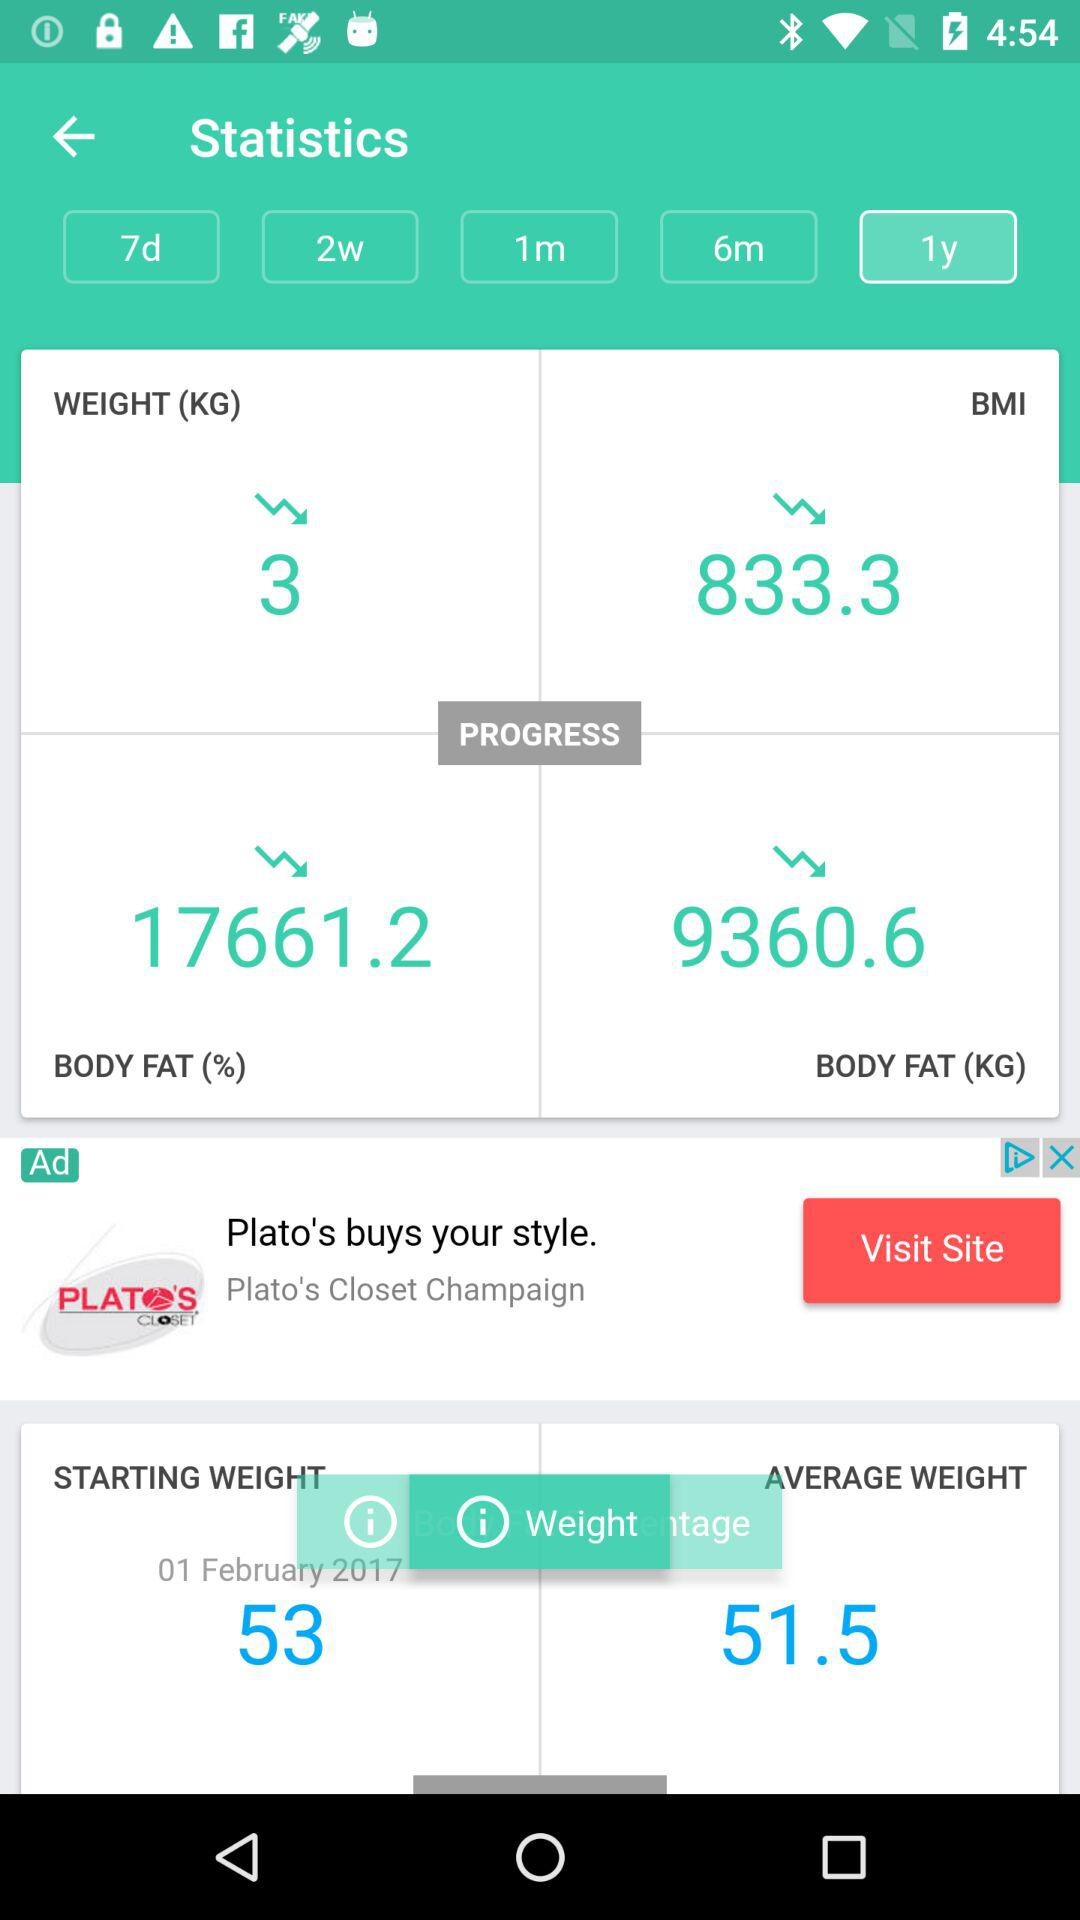How much weight dropped? The weight dropped by 3 kg. 